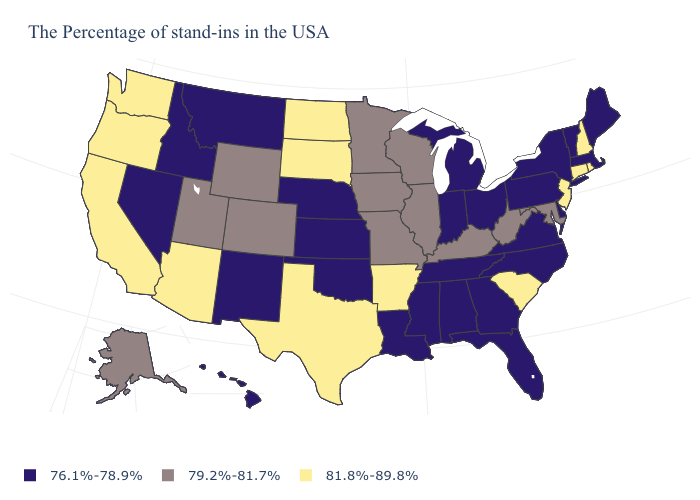What is the value of Virginia?
Be succinct. 76.1%-78.9%. Name the states that have a value in the range 76.1%-78.9%?
Answer briefly. Maine, Massachusetts, Vermont, New York, Delaware, Pennsylvania, Virginia, North Carolina, Ohio, Florida, Georgia, Michigan, Indiana, Alabama, Tennessee, Mississippi, Louisiana, Kansas, Nebraska, Oklahoma, New Mexico, Montana, Idaho, Nevada, Hawaii. What is the value of North Carolina?
Be succinct. 76.1%-78.9%. Is the legend a continuous bar?
Write a very short answer. No. What is the value of Hawaii?
Concise answer only. 76.1%-78.9%. What is the lowest value in the USA?
Answer briefly. 76.1%-78.9%. Does Rhode Island have the same value as New Mexico?
Quick response, please. No. Which states hav the highest value in the South?
Short answer required. South Carolina, Arkansas, Texas. What is the value of Alaska?
Write a very short answer. 79.2%-81.7%. Does New Jersey have the lowest value in the USA?
Give a very brief answer. No. What is the highest value in the West ?
Be succinct. 81.8%-89.8%. Which states have the lowest value in the USA?
Quick response, please. Maine, Massachusetts, Vermont, New York, Delaware, Pennsylvania, Virginia, North Carolina, Ohio, Florida, Georgia, Michigan, Indiana, Alabama, Tennessee, Mississippi, Louisiana, Kansas, Nebraska, Oklahoma, New Mexico, Montana, Idaho, Nevada, Hawaii. Among the states that border Washington , does Idaho have the lowest value?
Concise answer only. Yes. What is the value of Wisconsin?
Give a very brief answer. 79.2%-81.7%. 